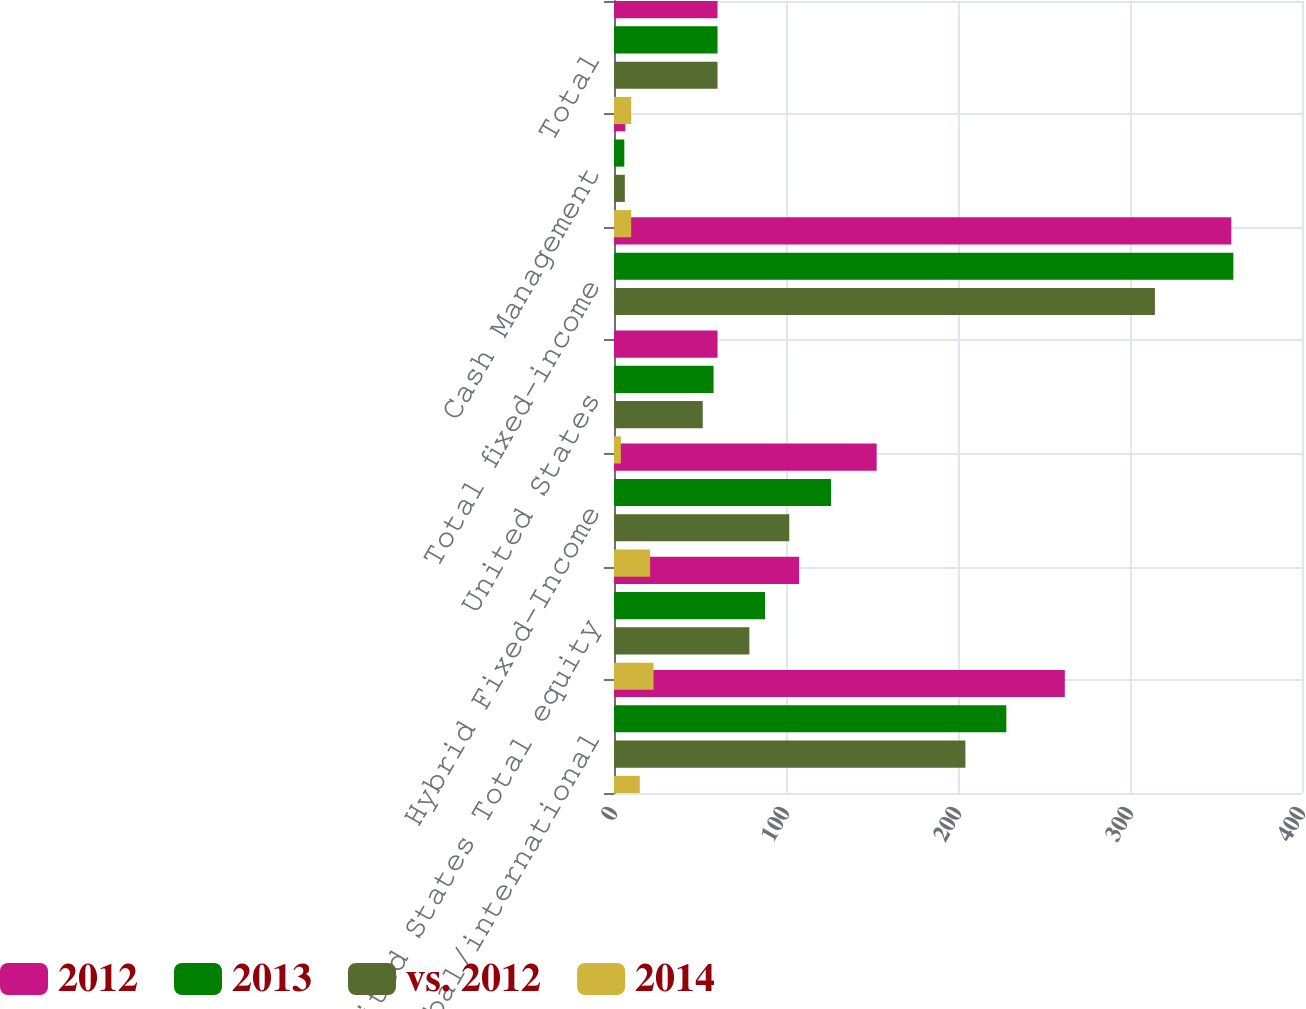Convert chart to OTSL. <chart><loc_0><loc_0><loc_500><loc_500><stacked_bar_chart><ecel><fcel>Global/international<fcel>United States Total equity<fcel>Hybrid Fixed-Income<fcel>United States<fcel>Total fixed-income<fcel>Cash Management<fcel>Total<nl><fcel>2012<fcel>262.1<fcel>107.6<fcel>152.7<fcel>60.2<fcel>358.9<fcel>6.6<fcel>60.2<nl><fcel>2013<fcel>228.1<fcel>87.8<fcel>126.2<fcel>57.9<fcel>360.1<fcel>6<fcel>60.2<nl><fcel>vs. 2012<fcel>204.3<fcel>78.7<fcel>101.9<fcel>51.6<fcel>314.5<fcel>6.3<fcel>60.2<nl><fcel>2014<fcel>15<fcel>23<fcel>21<fcel>4<fcel>0<fcel>10<fcel>10<nl></chart> 